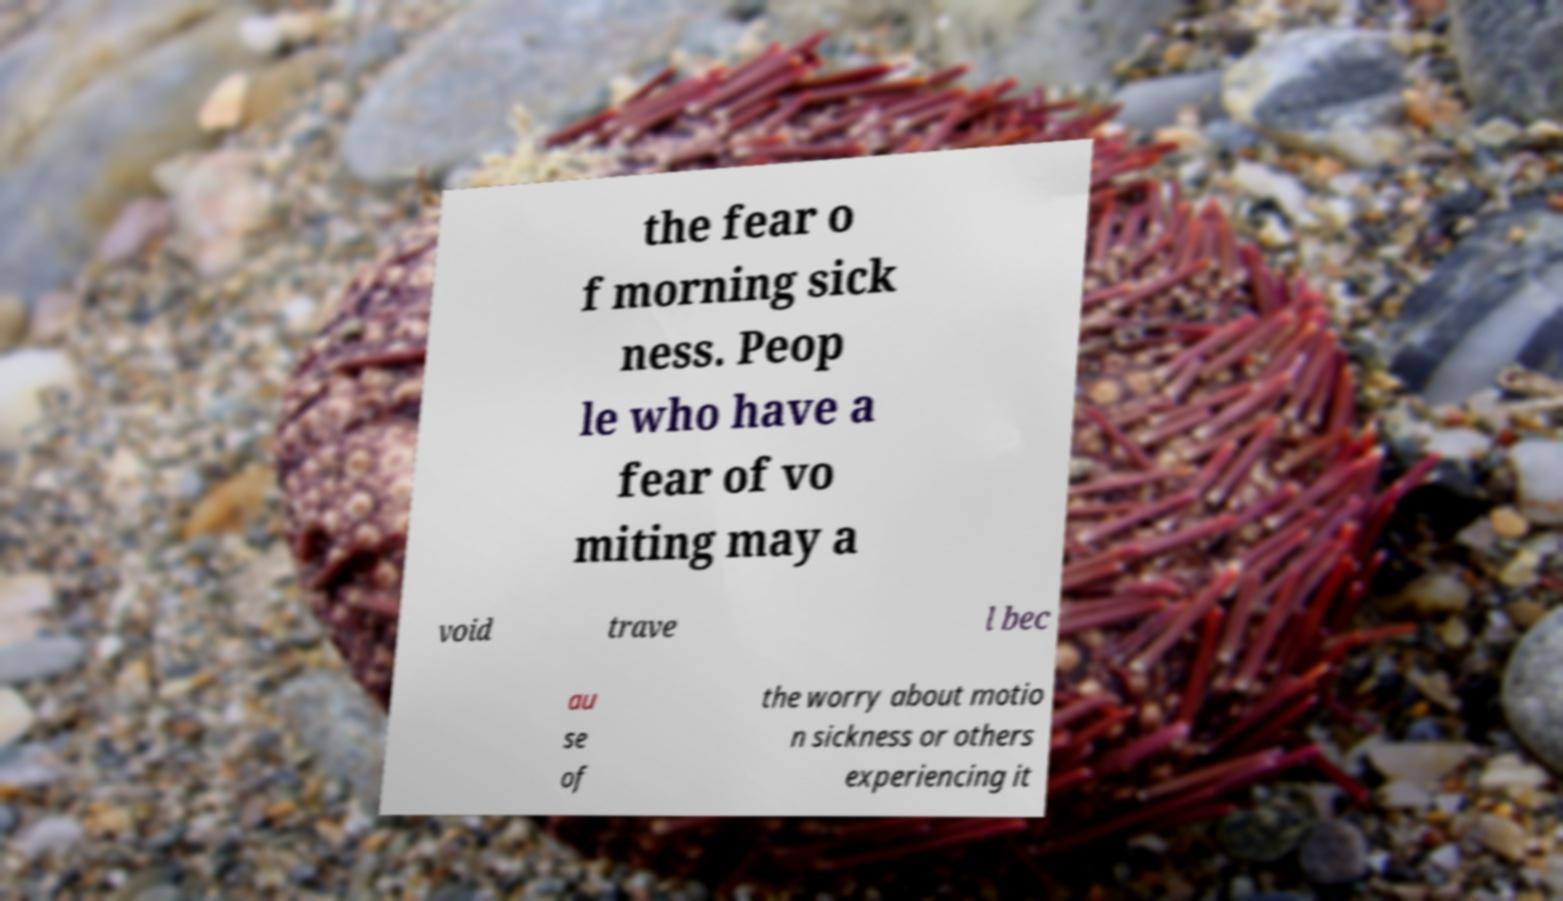Can you read and provide the text displayed in the image?This photo seems to have some interesting text. Can you extract and type it out for me? the fear o f morning sick ness. Peop le who have a fear of vo miting may a void trave l bec au se of the worry about motio n sickness or others experiencing it 